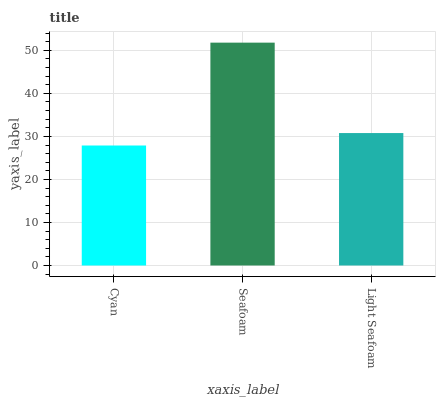Is Cyan the minimum?
Answer yes or no. Yes. Is Seafoam the maximum?
Answer yes or no. Yes. Is Light Seafoam the minimum?
Answer yes or no. No. Is Light Seafoam the maximum?
Answer yes or no. No. Is Seafoam greater than Light Seafoam?
Answer yes or no. Yes. Is Light Seafoam less than Seafoam?
Answer yes or no. Yes. Is Light Seafoam greater than Seafoam?
Answer yes or no. No. Is Seafoam less than Light Seafoam?
Answer yes or no. No. Is Light Seafoam the high median?
Answer yes or no. Yes. Is Light Seafoam the low median?
Answer yes or no. Yes. Is Cyan the high median?
Answer yes or no. No. Is Seafoam the low median?
Answer yes or no. No. 